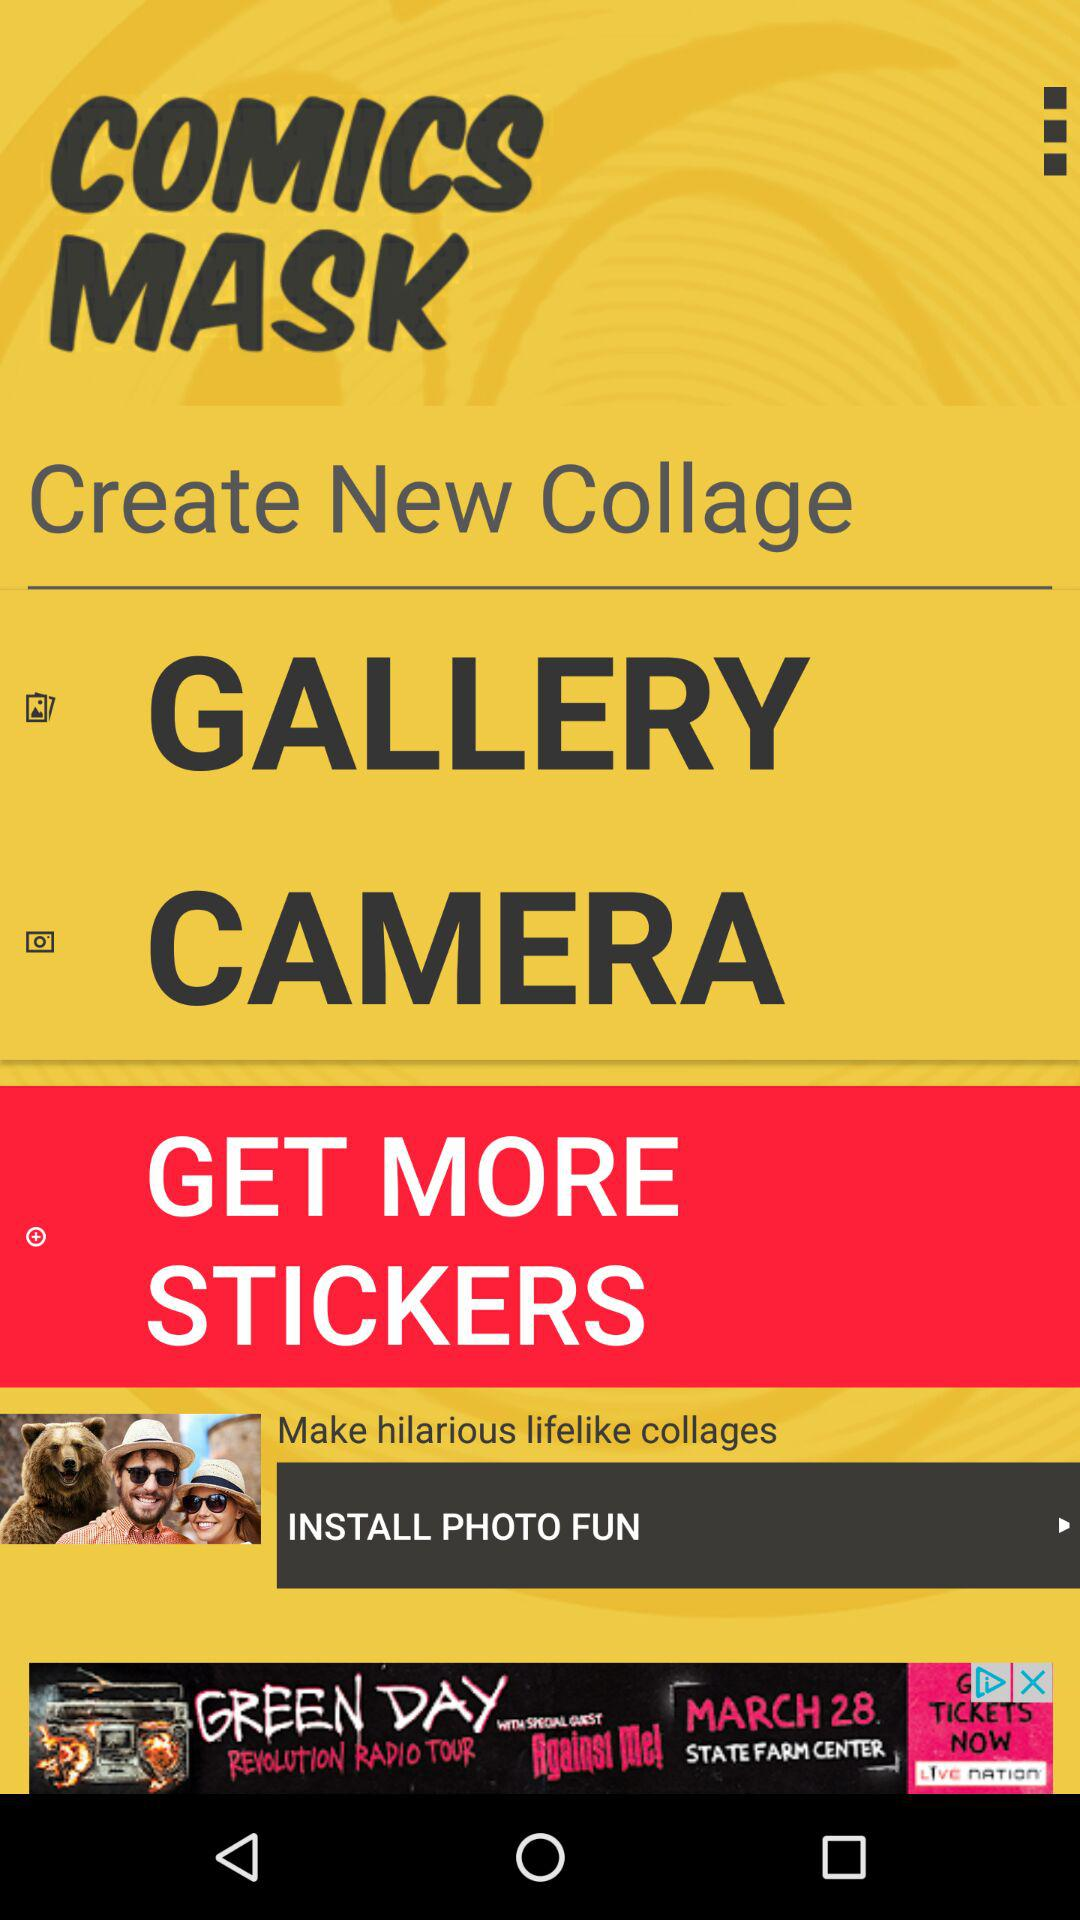What is the app name? The app name is "COMICS MASK". 